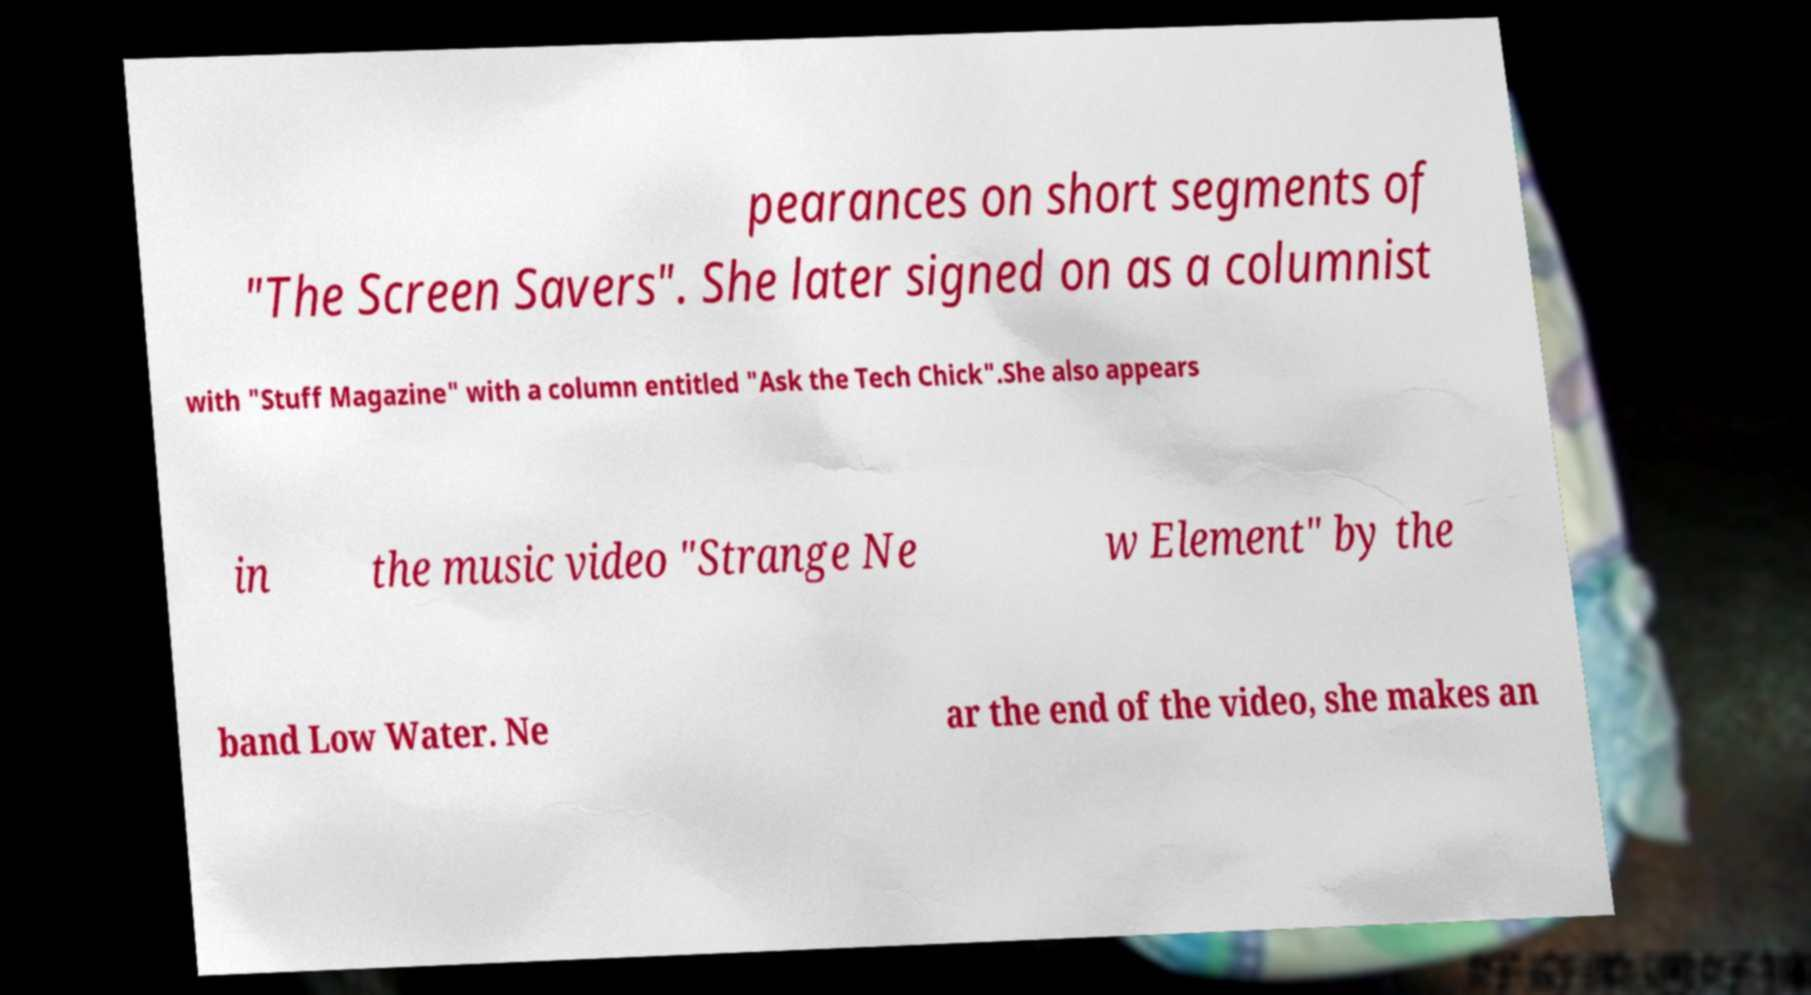Can you read and provide the text displayed in the image?This photo seems to have some interesting text. Can you extract and type it out for me? pearances on short segments of "The Screen Savers". She later signed on as a columnist with "Stuff Magazine" with a column entitled "Ask the Tech Chick".She also appears in the music video "Strange Ne w Element" by the band Low Water. Ne ar the end of the video, she makes an 